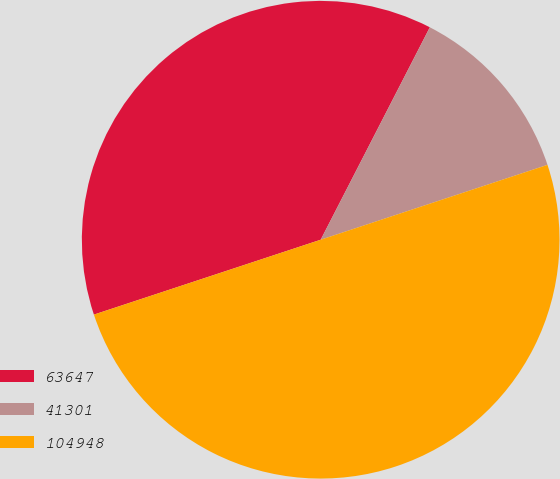Convert chart to OTSL. <chart><loc_0><loc_0><loc_500><loc_500><pie_chart><fcel>63647<fcel>41301<fcel>104948<nl><fcel>37.63%<fcel>12.37%<fcel>50.0%<nl></chart> 